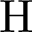<formula> <loc_0><loc_0><loc_500><loc_500>H</formula> 